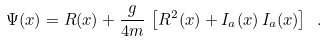Convert formula to latex. <formula><loc_0><loc_0><loc_500><loc_500>\Psi ( x ) = R ( x ) + \frac { g } { 4 m } \, \left [ R ^ { 2 } ( x ) + I _ { a } ( x ) \, I _ { a } ( x ) \right ] \ .</formula> 